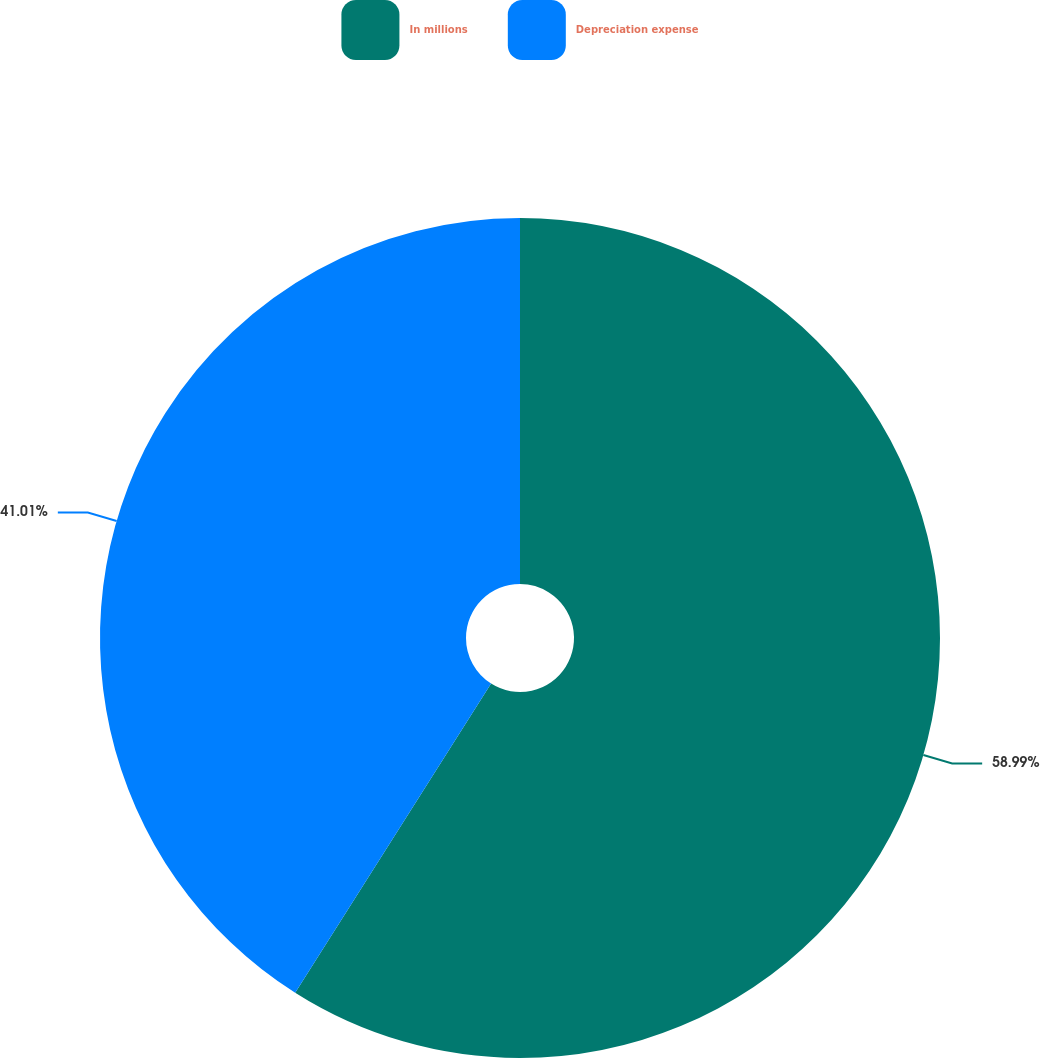Convert chart to OTSL. <chart><loc_0><loc_0><loc_500><loc_500><pie_chart><fcel>In millions<fcel>Depreciation expense<nl><fcel>58.99%<fcel>41.01%<nl></chart> 